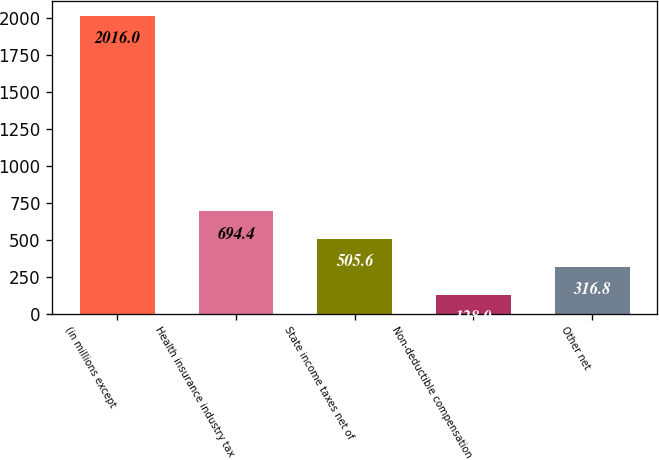Convert chart. <chart><loc_0><loc_0><loc_500><loc_500><bar_chart><fcel>(in millions except<fcel>Health insurance industry tax<fcel>State income taxes net of<fcel>Non-deductible compensation<fcel>Other net<nl><fcel>2016<fcel>694.4<fcel>505.6<fcel>128<fcel>316.8<nl></chart> 